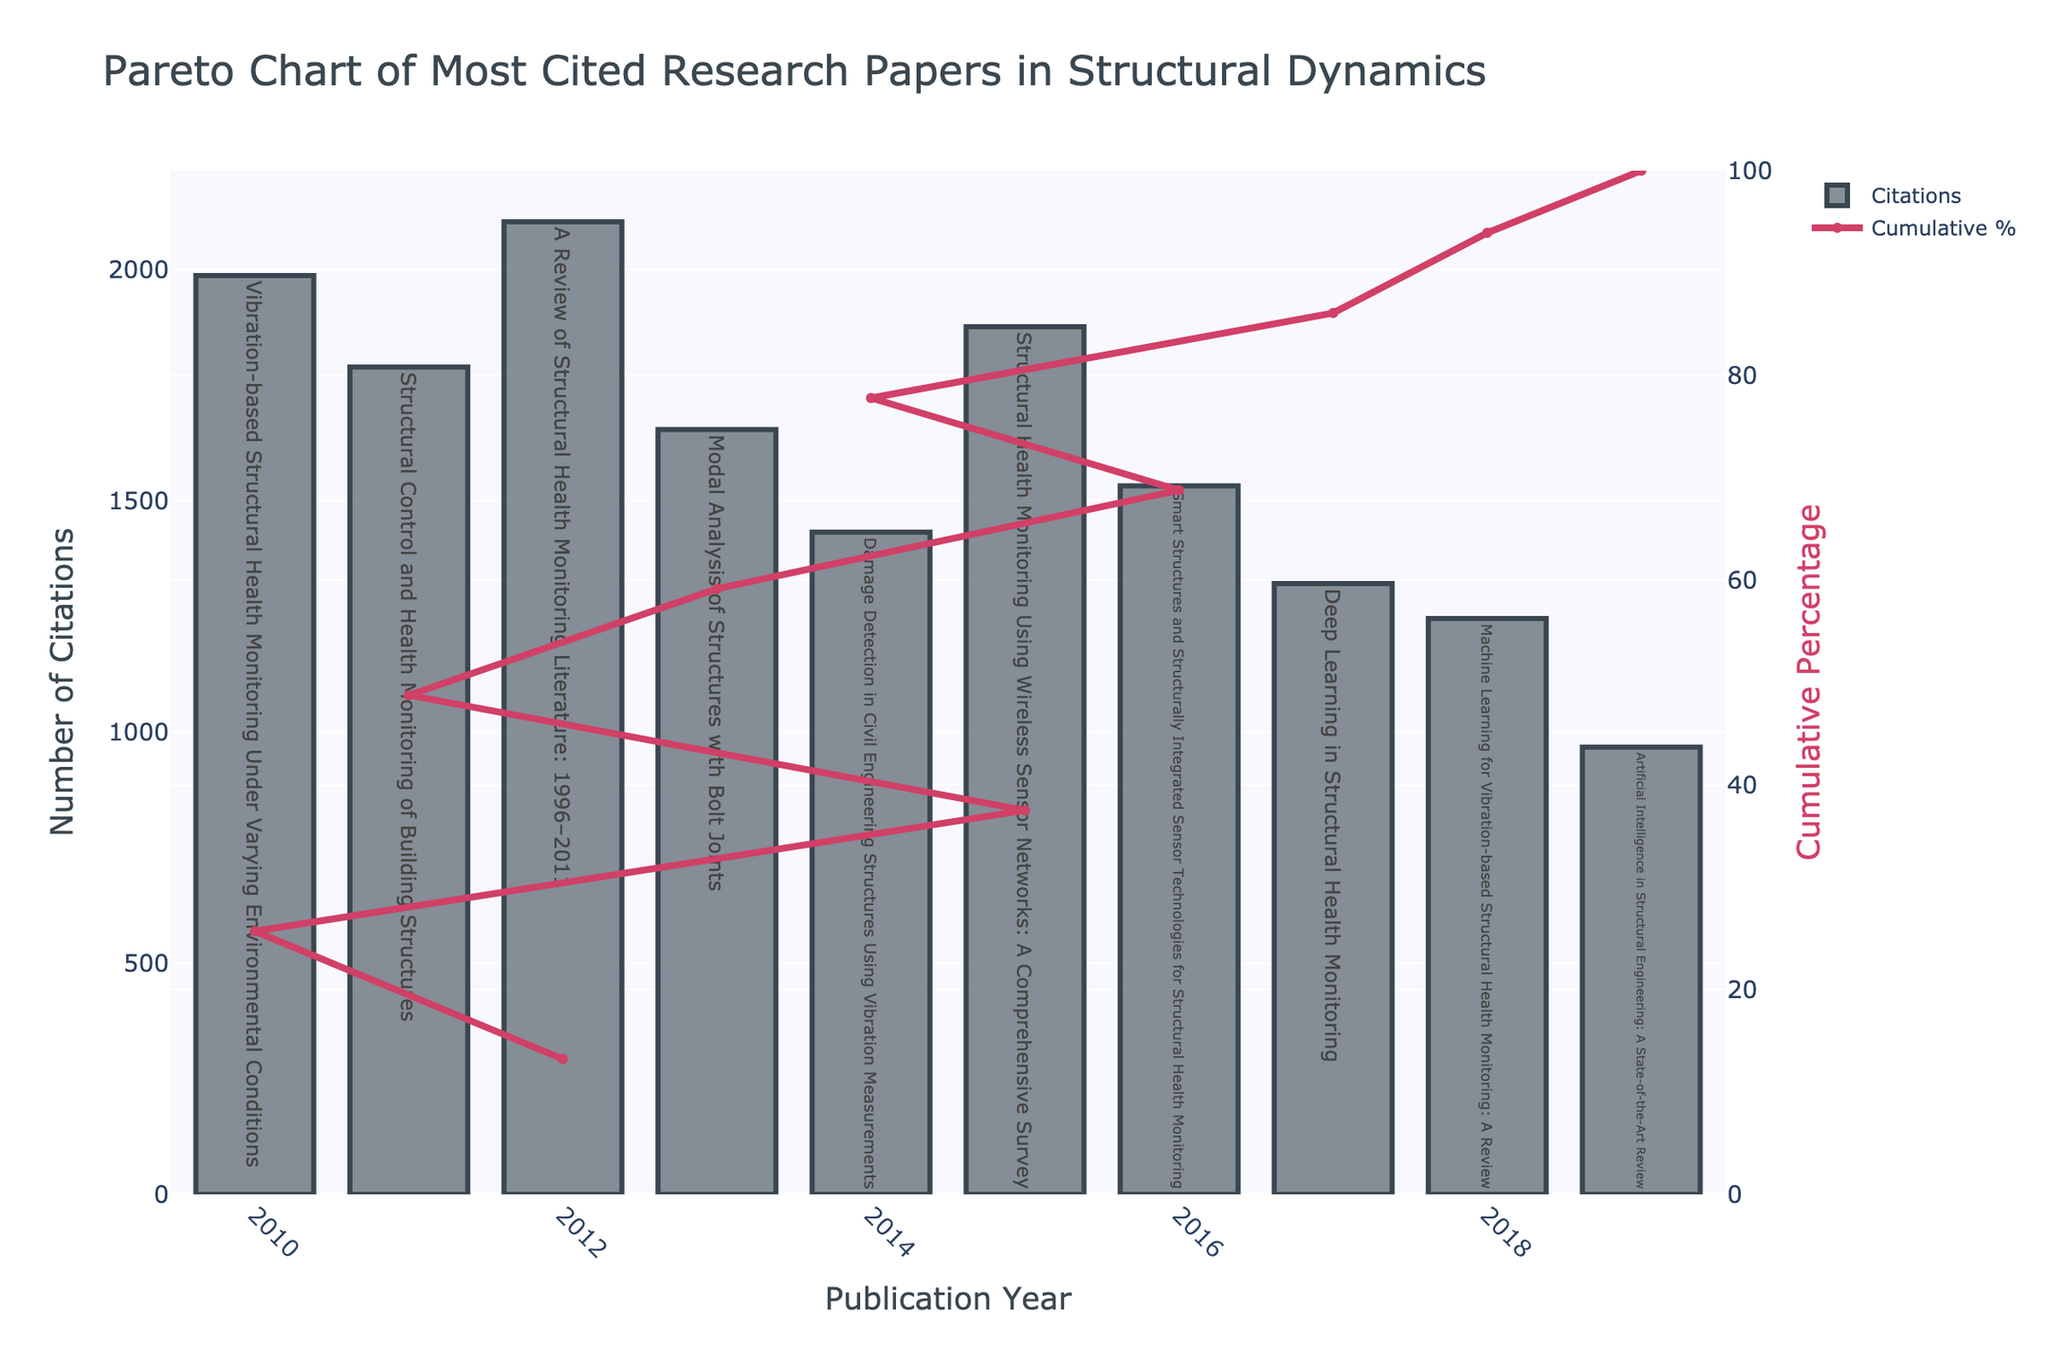What is the title of the figure? The title is always displayed at the top of the figure and indicates what the figure is about. In this case, it is about the most cited research papers in structural dynamics, displayed in the form of a Pareto chart.
Answer: Pareto Chart of Most Cited Research Papers in Structural Dynamics How many research papers are represented in the figure? The number of research papers corresponds to the number of bars in the bar chart. Counting each bar will give the total number of research papers presented.
Answer: 10 What year has the highest number of citations? The bar with the highest value on the y-axis indicates the year with the highest number of citations.
Answer: 2012 Which research paper has the least number of citations? The bar with the lowest value on the y-axis represents the research paper with the least number of citations. Checking the hover text for that bar will provide the paper's title.
Answer: Artificial Intelligence in Structural Engineering: A State-of-the-Art Review What is the cumulative percentage for the year 2018? The cumulative percentage can be seen from the line graph at the point corresponding to the year 2018 on the x-axis. It shows how far along the cumulative sum has progressed by that year.
Answer: Around 66% What is the total number of citations for papers published before 2015? To find this, add the number of citations for papers published in 2010, 2011, 2012, and 2013.
Answer: 1654 (2013) + 2103 (2012) + 1987 (2010) + 1789 (2011) = 7533 Which year had more citations: 2014 or 2019? Compare the heights of the bars for the years 2014 and 2019 and read the y-axis values or check the hover text.
Answer: 2014 What percentage of total citations is accounted for by the papers published in 2010 and 2012 combined? First, find the total citations of these two years, then divide by the overall total number of citations and multiply by 100 to get the percentage.
Answer: (1987 + 2103) / (sum of all citations) * 100 ≈ 33.2% Which paper, titled "Smart Structures and Structurally Integrated Sensor Technologies for Structural Health Monitoring," has how many citations? Find the bar that corresponds to this paper's title in the hover text and note its height to read the number of citations.
Answer: 1532 What is the cumulative percentage after 2016? Follow the cumulative percentage line on the secondary y-axis to the year 2016 and note the value.
Answer: Around 71% 